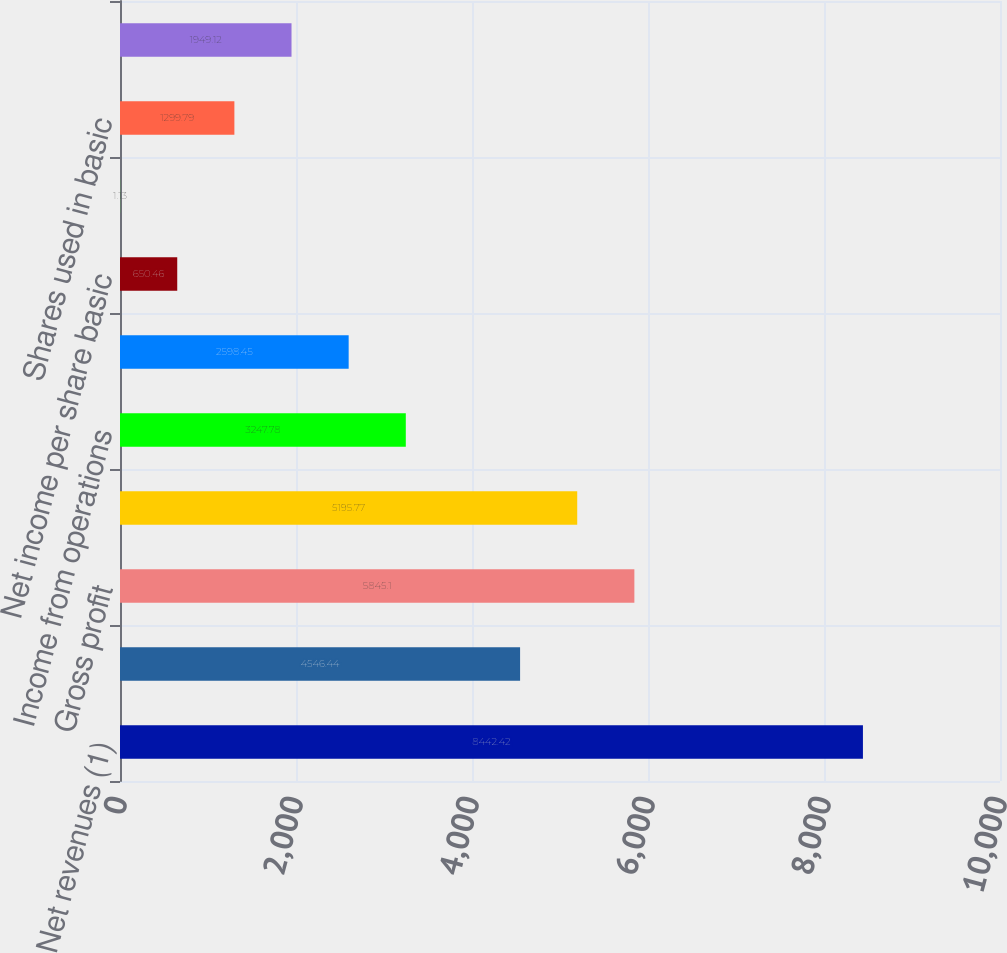Convert chart. <chart><loc_0><loc_0><loc_500><loc_500><bar_chart><fcel>Net revenues (1)<fcel>Total cost of revenues<fcel>Gross profit<fcel>Total operating expenses<fcel>Income from operations<fcel>Net income (1)<fcel>Net income per share basic<fcel>Net income per share diluted<fcel>Shares used in basic<fcel>Shares used in diluted<nl><fcel>8442.42<fcel>4546.44<fcel>5845.1<fcel>5195.77<fcel>3247.78<fcel>2598.45<fcel>650.46<fcel>1.13<fcel>1299.79<fcel>1949.12<nl></chart> 